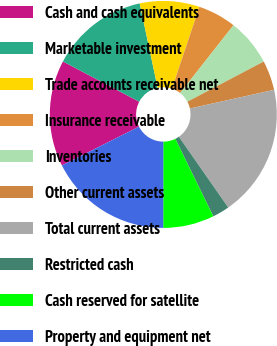Convert chart to OTSL. <chart><loc_0><loc_0><loc_500><loc_500><pie_chart><fcel>Cash and cash equivalents<fcel>Marketable investment<fcel>Trade accounts receivable net<fcel>Insurance receivable<fcel>Inventories<fcel>Other current assets<fcel>Total current assets<fcel>Restricted cash<fcel>Cash reserved for satellite<fcel>Property and equipment net<nl><fcel>15.15%<fcel>13.94%<fcel>8.49%<fcel>5.46%<fcel>6.67%<fcel>4.24%<fcel>18.79%<fcel>2.43%<fcel>7.27%<fcel>17.57%<nl></chart> 